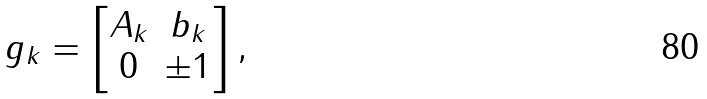Convert formula to latex. <formula><loc_0><loc_0><loc_500><loc_500>g _ { k } = \begin{bmatrix} A _ { k } & b _ { k } \\ 0 & \pm 1 \end{bmatrix} ,</formula> 